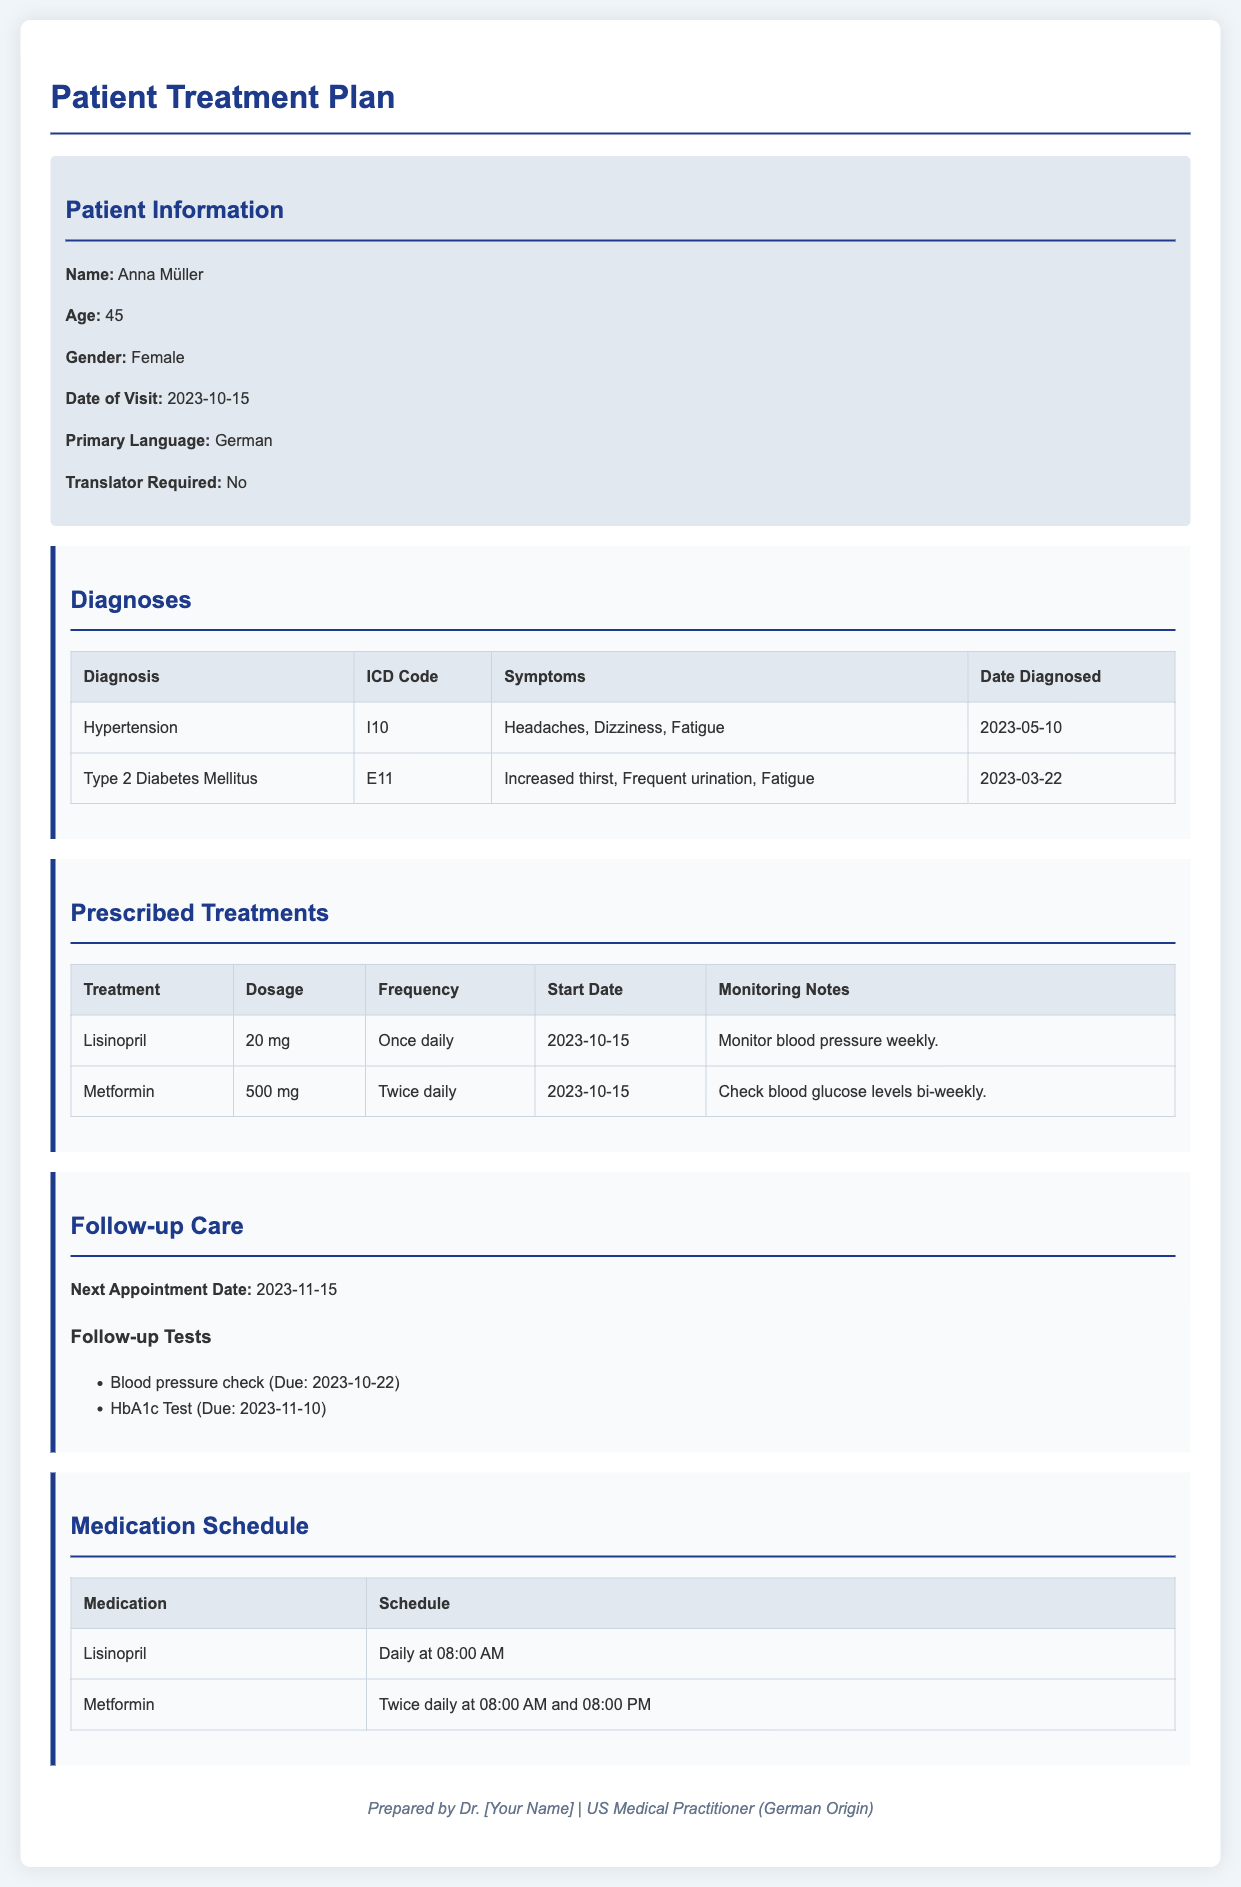What is the patient's name? The patient's name is displayed at the beginning of the document under Patient Information.
Answer: Anna Müller What is the ICD code for Type 2 Diabetes Mellitus? The ICD code is found in the Diagnoses section of the document.
Answer: E11 What is the dosage for Lisinopril? The dosage is indicated in the Prescribed Treatments section of the document.
Answer: 20 mg When is the next follow-up appointment scheduled? The date for the next appointment is mentioned in the Follow-up Care section.
Answer: 2023-11-15 What symptoms are associated with Hypertension? Symptoms are listed in the Diagnoses table in the document.
Answer: Headaches, Dizziness, Fatigue Which test is due on 2023-11-10? This information can be found in the list of follow-up tests under Follow-up Care.
Answer: HbA1c Test What is the frequency of Metformin dosage? The frequency is specified in the Prescribed Treatments section of the document.
Answer: Twice daily What time is Lisinopril scheduled to be taken? The schedule is detailed in the Medication Schedule table.
Answer: Daily at 08:00 AM What is the start date for Metformin treatment? The start date is indicated in the Prescribed Treatments section.
Answer: 2023-10-15 